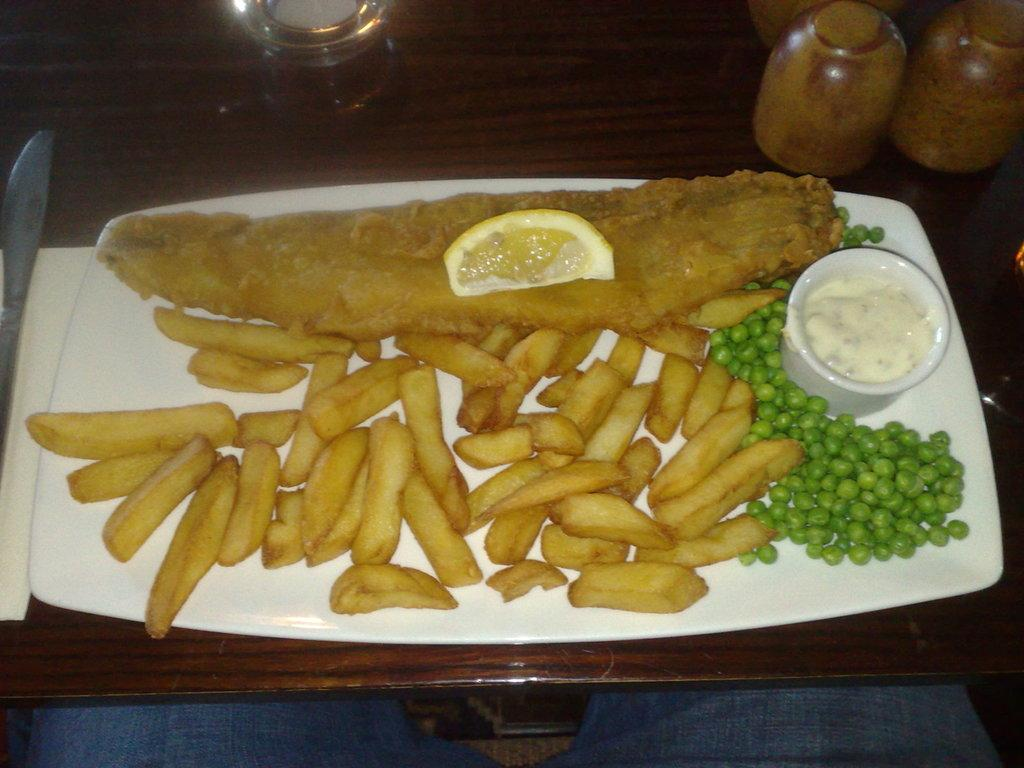What type of food is visible in the image? There are potato fries in the image. What other food item can be seen in the image? There is a lemon piece and boiled peas in the image. What is used to add flavor to the food? There is sauce in the image. What color is the plate that the food is served on? The plate is white. Where is the plate with the food placed? The plate is kept on a table. What type of soup is being served in the image? There is no soup present in the image; it features potato fries, lemon piece, boiled peas, sauce, and a white plate. How many tails can be seen in the image? There are no tails visible in the image. 